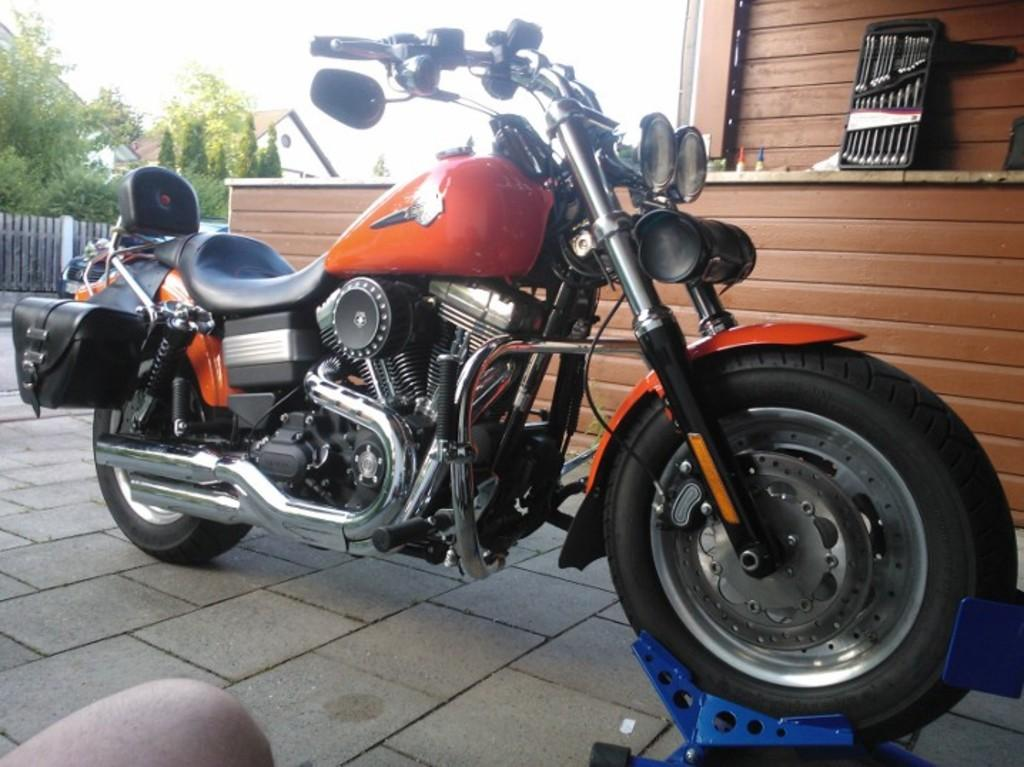What is the main object in the image? There is a bike in the image. Can you describe the color of the bike? The bike is black and brown in color. What can be seen in the background of the image? There is a building, trees, and the sky visible in the background of the image. How would you describe the color of the building? The building is white in color. What is the color of the trees in the background? The trees are green in color. How would you describe the color of the sky in the background? The sky is white in color. What type of juice is being served in the image? There is no juice present in the image; it features a bike and a background with a building, trees, and the sky. Is there a cork visible in the image? There is no cork present in the image. 